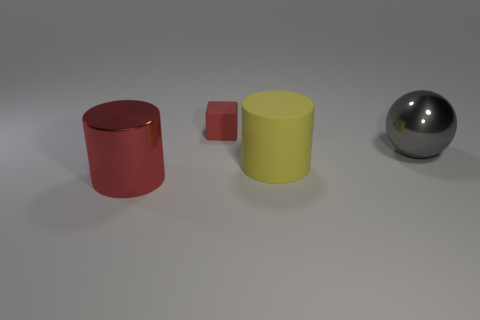There is a red thing that is behind the rubber thing on the right side of the small object; are there any red matte objects that are behind it?
Keep it short and to the point. No. What material is the object behind the large sphere?
Make the answer very short. Rubber. How many large things are either yellow matte blocks or red cubes?
Ensure brevity in your answer.  0. Is the size of the metallic object behind the red shiny cylinder the same as the red cylinder?
Your response must be concise. Yes. What number of other things are the same color as the rubber cylinder?
Ensure brevity in your answer.  0. What material is the gray object?
Make the answer very short. Metal. There is a object that is both to the right of the cube and on the left side of the large gray metallic thing; what material is it made of?
Offer a very short reply. Rubber. How many things are either cylinders that are right of the red block or large metal things?
Your answer should be very brief. 3. Is the small thing the same color as the metal cylinder?
Keep it short and to the point. Yes. Is there a matte cylinder that has the same size as the ball?
Your answer should be very brief. Yes. 